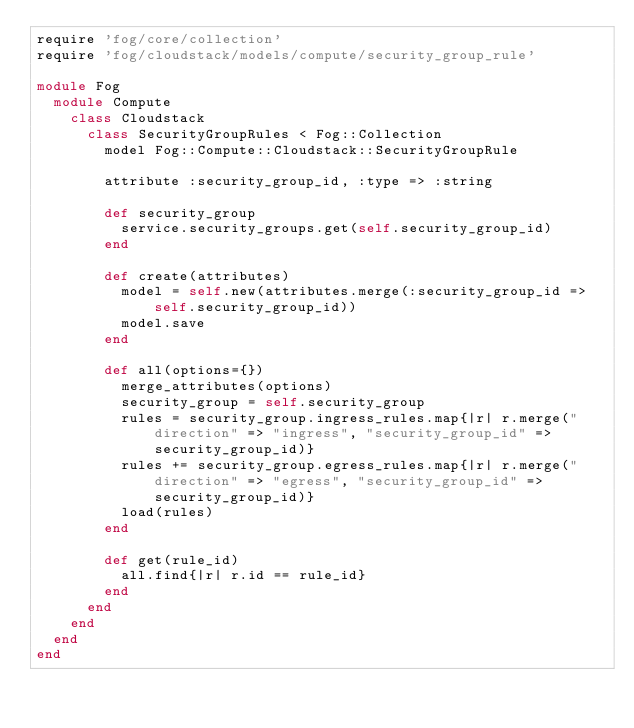Convert code to text. <code><loc_0><loc_0><loc_500><loc_500><_Ruby_>require 'fog/core/collection'
require 'fog/cloudstack/models/compute/security_group_rule'

module Fog
  module Compute
    class Cloudstack
      class SecurityGroupRules < Fog::Collection
        model Fog::Compute::Cloudstack::SecurityGroupRule

        attribute :security_group_id, :type => :string

        def security_group
          service.security_groups.get(self.security_group_id)
        end

        def create(attributes)
          model = self.new(attributes.merge(:security_group_id => self.security_group_id))
          model.save
        end

        def all(options={})
          merge_attributes(options)
          security_group = self.security_group
          rules = security_group.ingress_rules.map{|r| r.merge("direction" => "ingress", "security_group_id" => security_group_id)}
          rules += security_group.egress_rules.map{|r| r.merge("direction" => "egress", "security_group_id" => security_group_id)}
          load(rules)
        end

        def get(rule_id)
          all.find{|r| r.id == rule_id}
        end
      end
    end
  end
end
</code> 